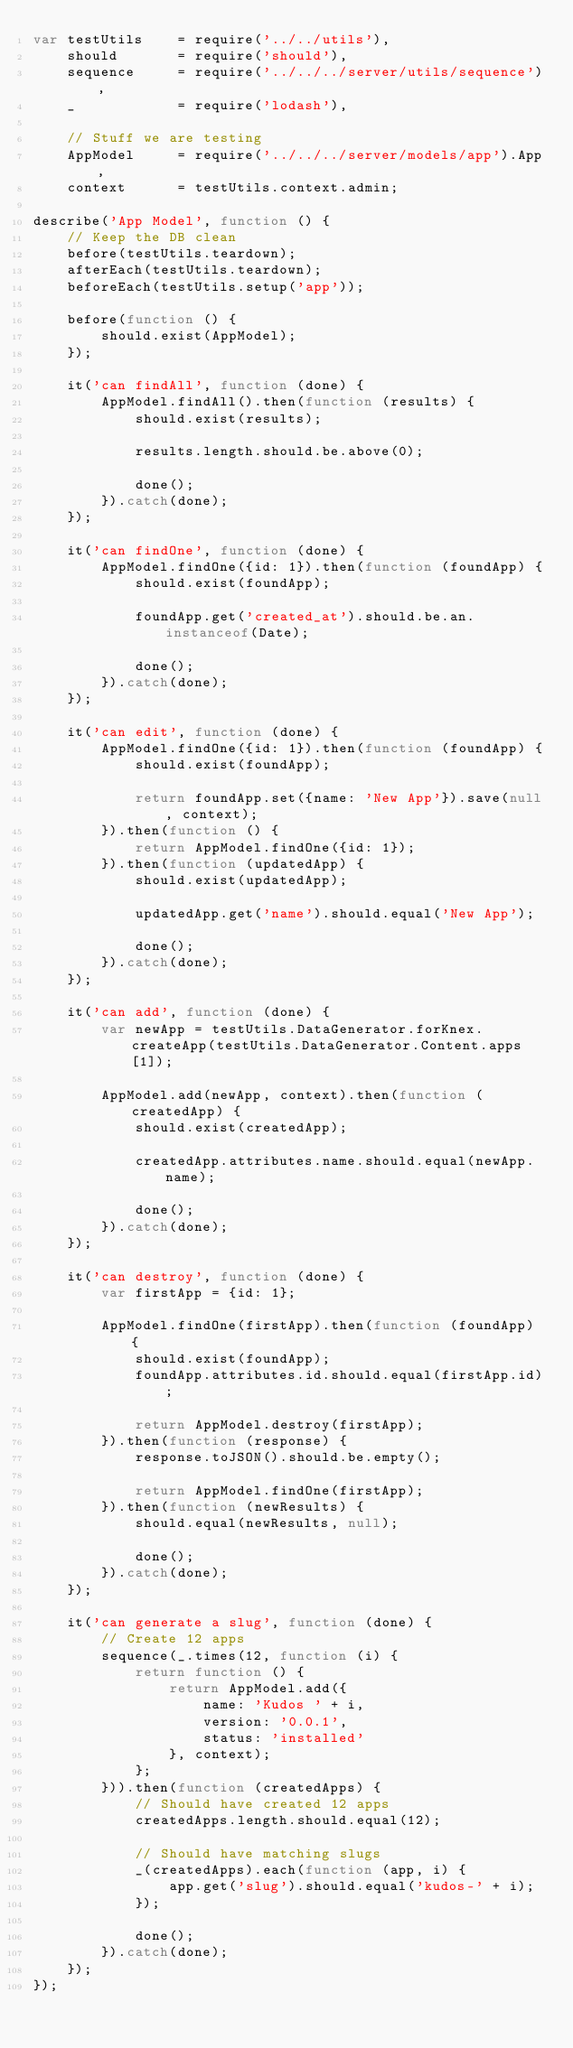<code> <loc_0><loc_0><loc_500><loc_500><_JavaScript_>var testUtils    = require('../../utils'),
    should       = require('should'),
    sequence     = require('../../../server/utils/sequence'),
    _            = require('lodash'),

    // Stuff we are testing
    AppModel     = require('../../../server/models/app').App,
    context      = testUtils.context.admin;

describe('App Model', function () {
    // Keep the DB clean
    before(testUtils.teardown);
    afterEach(testUtils.teardown);
    beforeEach(testUtils.setup('app'));

    before(function () {
        should.exist(AppModel);
    });

    it('can findAll', function (done) {
        AppModel.findAll().then(function (results) {
            should.exist(results);

            results.length.should.be.above(0);

            done();
        }).catch(done);
    });

    it('can findOne', function (done) {
        AppModel.findOne({id: 1}).then(function (foundApp) {
            should.exist(foundApp);

            foundApp.get('created_at').should.be.an.instanceof(Date);

            done();
        }).catch(done);
    });

    it('can edit', function (done) {
        AppModel.findOne({id: 1}).then(function (foundApp) {
            should.exist(foundApp);

            return foundApp.set({name: 'New App'}).save(null, context);
        }).then(function () {
            return AppModel.findOne({id: 1});
        }).then(function (updatedApp) {
            should.exist(updatedApp);

            updatedApp.get('name').should.equal('New App');

            done();
        }).catch(done);
    });

    it('can add', function (done) {
        var newApp = testUtils.DataGenerator.forKnex.createApp(testUtils.DataGenerator.Content.apps[1]);

        AppModel.add(newApp, context).then(function (createdApp) {
            should.exist(createdApp);

            createdApp.attributes.name.should.equal(newApp.name);

            done();
        }).catch(done);
    });

    it('can destroy', function (done) {
        var firstApp = {id: 1};

        AppModel.findOne(firstApp).then(function (foundApp) {
            should.exist(foundApp);
            foundApp.attributes.id.should.equal(firstApp.id);

            return AppModel.destroy(firstApp);
        }).then(function (response) {
            response.toJSON().should.be.empty();

            return AppModel.findOne(firstApp);
        }).then(function (newResults) {
            should.equal(newResults, null);

            done();
        }).catch(done);
    });

    it('can generate a slug', function (done) {
        // Create 12 apps
        sequence(_.times(12, function (i) {
            return function () {
                return AppModel.add({
                    name: 'Kudos ' + i,
                    version: '0.0.1',
                    status: 'installed'
                }, context);
            };
        })).then(function (createdApps) {
            // Should have created 12 apps
            createdApps.length.should.equal(12);

            // Should have matching slugs
            _(createdApps).each(function (app, i) {
                app.get('slug').should.equal('kudos-' + i);
            });

            done();
        }).catch(done);
    });
});
</code> 